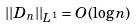Convert formula to latex. <formula><loc_0><loc_0><loc_500><loc_500>| | D _ { n } | | _ { L ^ { 1 } } = O ( \log n )</formula> 